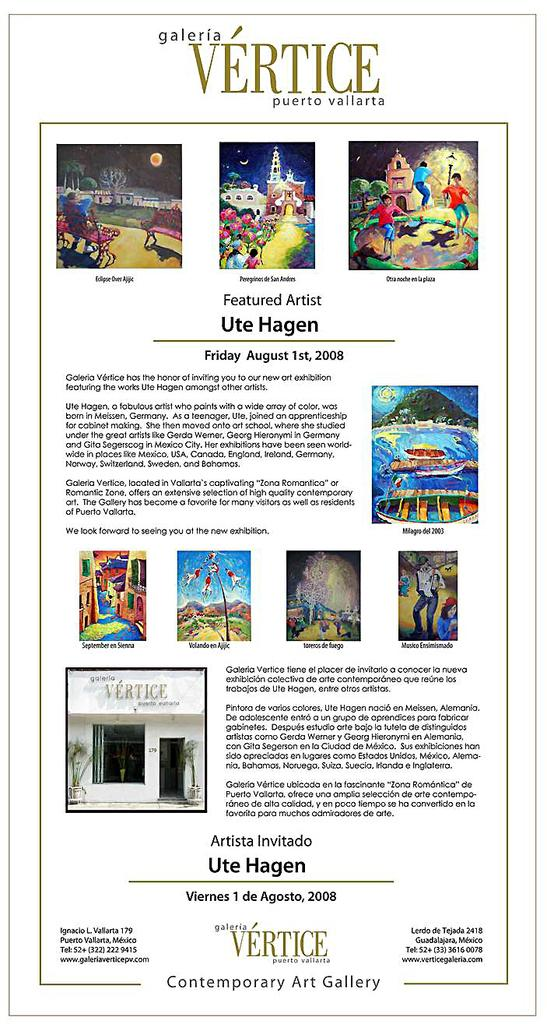What is the main subject of the poster in the image? The poster contains pictures of people, a hill, buildings, trees, the sky, and objects. What is written on the poster? There is text written on the poster. What type of fruit is being held by the writer in the image? There is no writer or fruit present in the image; the poster contains pictures of people, but not a writer holding fruit. What color is the brick used to build the buildings in the image? There is no brick visible in the image, as the poster contains pictures of buildings but not their construction materials. 